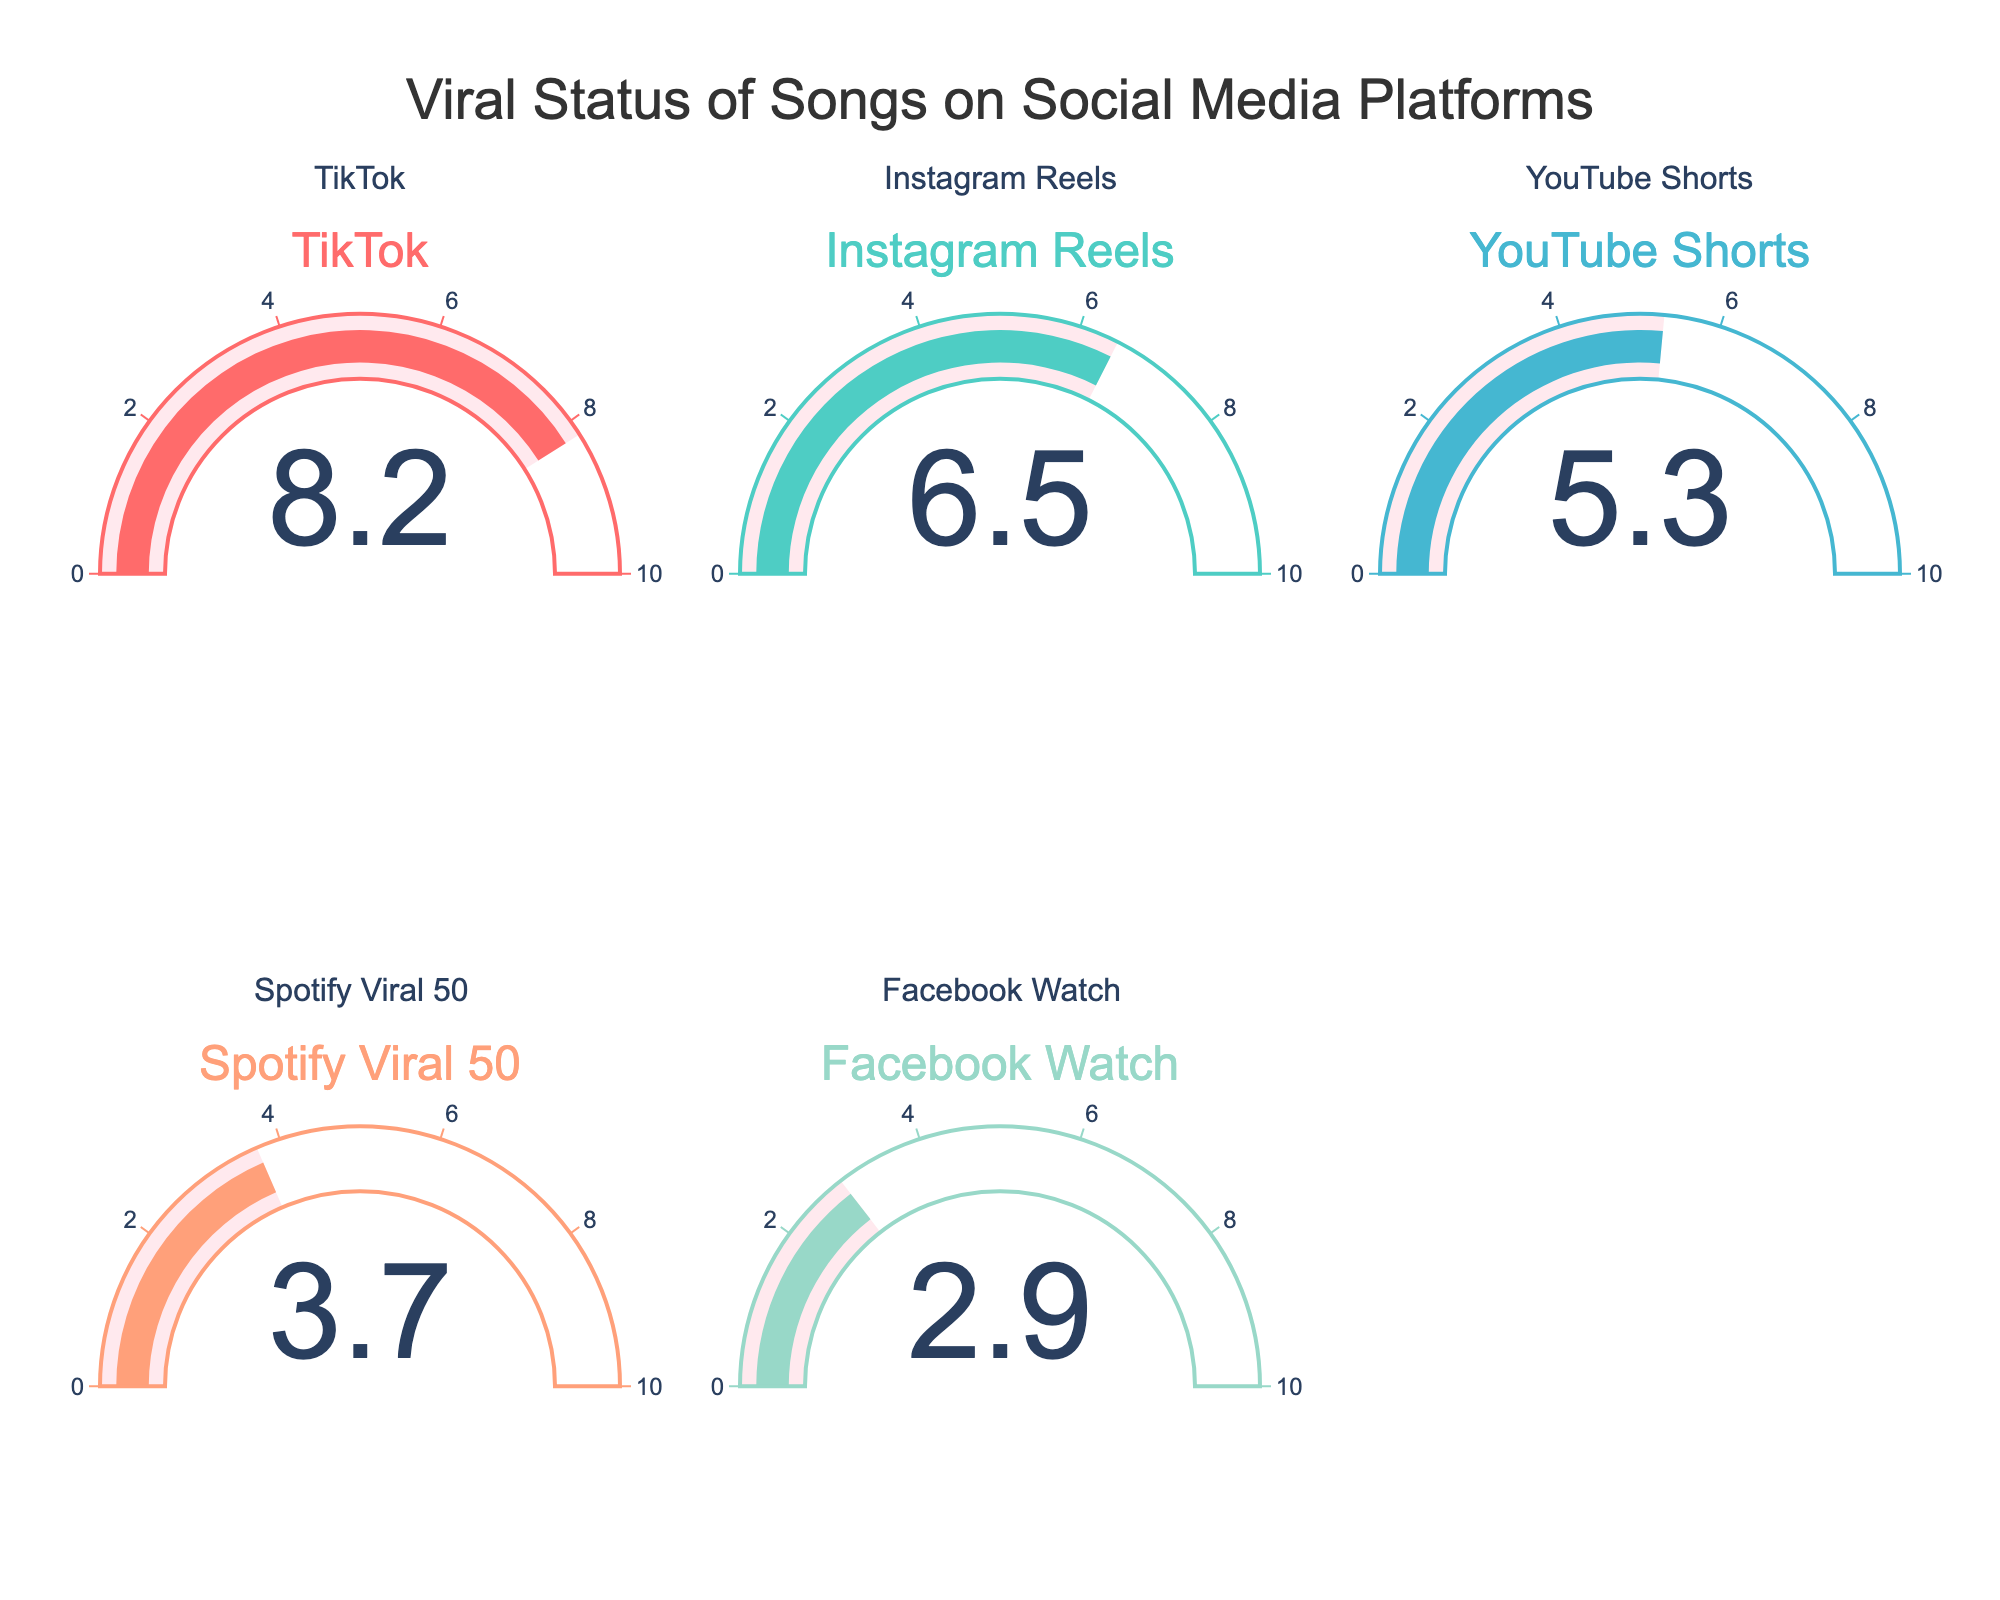what is the highest viral percentage displayed in the chart? The chart shows the viral percentages for various social media platforms. The highest gauge shows a value of 8.2% for TikTok.
Answer: 8.2% Which platform has the lowest viral percentage? By comparing all the gauges, the lowest value is displayed for Facebook Watch at 2.9%.
Answer: Facebook Watch What is the combined viral percentage for Instagram Reels and YouTube Shorts? Instagram Reels shows 6.5% and YouTube Shorts shows 5.3%. Summing these values gives 6.5 + 5.3 = 11.8.
Answer: 11.8% How many platforms have a viral percentage greater than 5%? By observing each gauge, TikTok (8.2%), Instagram Reels (6.5%), and YouTube Shorts (5.3%) are above 5%. This makes a total of 3 platforms.
Answer: 3 Which platform has a viral percentage closest to 4%? Comparing the values, Spotify Viral 50 at 3.7% is the closest to 4%.
Answer: Spotify Viral 50 Is the viral percentage for TikTok more than double that of Facebook Watch? TikTok's percentage is 8.2% and Facebook Watch is 2.9%. Doubling Facebook Watch's percentage gives 2.9 * 2 = 5.8. Since 8.2 > 5.8, TikTok's percentage is indeed more than double.
Answer: Yes What is the average viral percentage across all platforms? Sum the percentages of each platform: 8.2 + 6.5 + 5.3 + 3.7 + 2.9 = 26.6. Then divide by the number of platforms (5): 26.6 / 5 = 5.32.
Answer: 5.32% Which social media platforms have viral percentages within 1% of each other? Comparing values shows that Instagram Reels (6.5%) and YouTube Shorts (5.3%) differ by 1.2%, which is the closest pair but not within 1%. No pairs have percentages within 1%.
Answer: None What is the range of the viral percentages displayed? The range is calculated as the difference between the highest (8.2% for TikTok) and the lowest (2.9% for Facebook Watch) percentages: 8.2 - 2.9 = 5.3.
Answer: 5.3 What percentage of the total viral percentages does Spotify Viral 50 represent? The total viral percentage for all platforms is 26.6%. Spotify Viral 50 is 3.7%. The calculation is (3.7 / 26.6) * 100 ≈ 13.91%.
Answer: 13.91% 